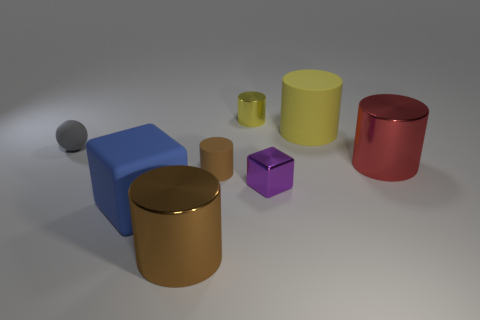What material is the blue thing that is the same shape as the small purple shiny object?
Provide a succinct answer. Rubber. What number of other blue cubes have the same size as the shiny cube?
Give a very brief answer. 0. Do the sphere and the blue rubber thing have the same size?
Your answer should be very brief. No. What size is the metal cylinder that is both in front of the large yellow cylinder and left of the large yellow thing?
Provide a short and direct response. Large. Are there more big rubber cubes right of the big red object than cylinders in front of the gray sphere?
Ensure brevity in your answer.  No. The other large shiny object that is the same shape as the big red thing is what color?
Keep it short and to the point. Brown. There is a big cylinder to the left of the yellow matte cylinder; is it the same color as the small rubber cylinder?
Offer a very short reply. Yes. What number of gray spheres are there?
Provide a short and direct response. 1. Are the large cylinder behind the small rubber ball and the tiny gray ball made of the same material?
Your answer should be compact. Yes. There is a metallic thing left of the brown cylinder that is behind the brown metallic object; how many red metal objects are on the left side of it?
Your response must be concise. 0. 